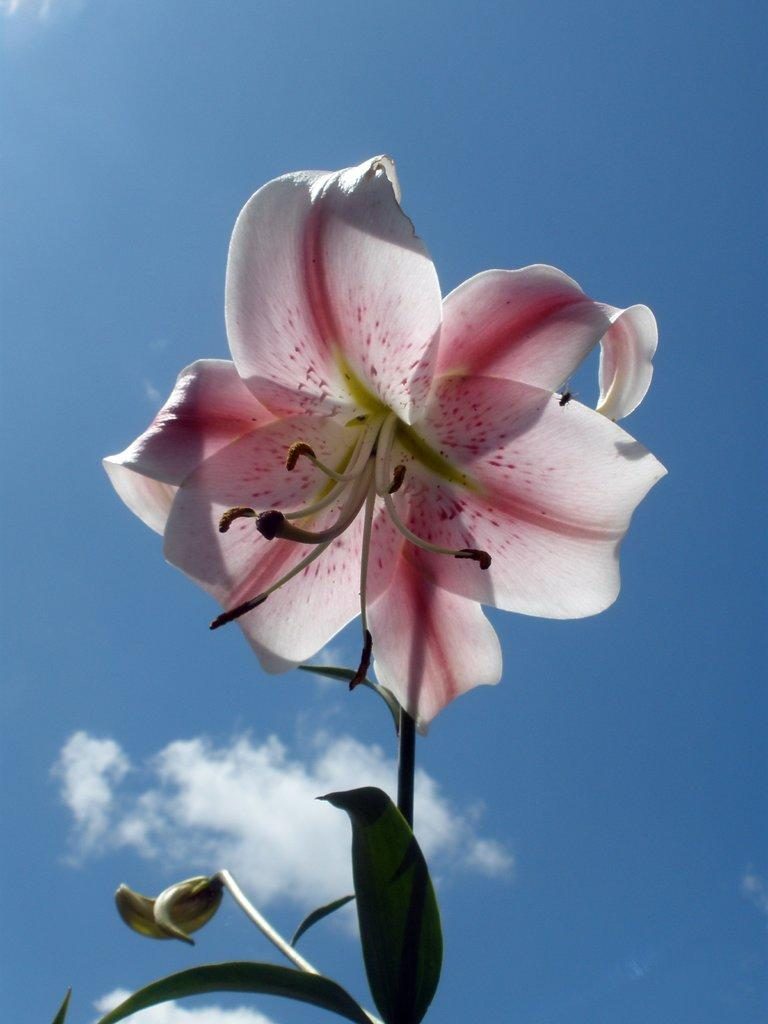Where was the image taken? The image was taken outdoors. What can be seen in the background of the image? There is a sky with clouds in the background. What is the main subject of the image? There is a plant in the middle of the image. What is special about the plant? The plant has a beautiful flower. What color is the flower? The flower is pink in color. What type of treatment is being administered to the plant in the image? There is no indication in the image that the plant is receiving any treatment. 